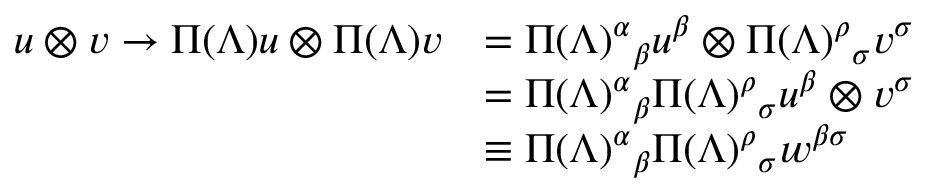Convert formula to latex. <formula><loc_0><loc_0><loc_500><loc_500>{ \begin{array} { r l } { u \otimes v \rightarrow \Pi ( \Lambda ) u \otimes \Pi ( \Lambda ) v } & { = { \Pi ( \Lambda ) ^ { \alpha } } _ { \beta } u ^ { \beta } \otimes { \Pi ( \Lambda ) ^ { \rho } } _ { \sigma } v ^ { \sigma } } \\ & { = { \Pi ( \Lambda ) ^ { \alpha } } _ { \beta } { \Pi ( \Lambda ) ^ { \rho } } _ { \sigma } u ^ { \beta } \otimes v ^ { \sigma } } \\ & { \equiv \Pi ( \Lambda ) ^ { \alpha } _ { \beta } { \Pi ( \Lambda ) ^ { \rho } } _ { \sigma } w ^ { \beta \sigma } } \end{array} }</formula> 